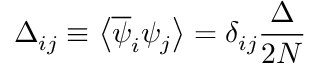<formula> <loc_0><loc_0><loc_500><loc_500>\Delta _ { i j } \equiv \left \langle \overline { \psi } _ { i } \psi _ { j } \right \rangle = \delta _ { i j } \frac { \Delta } { 2 N }</formula> 